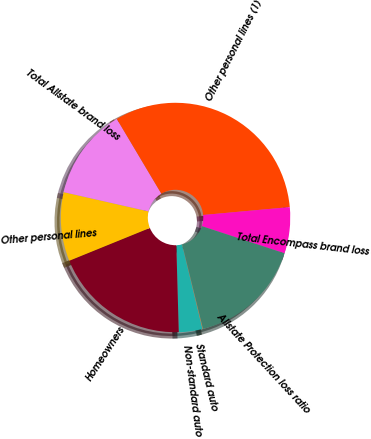Convert chart. <chart><loc_0><loc_0><loc_500><loc_500><pie_chart><fcel>Standard auto<fcel>Non-standard auto<fcel>Homeowners<fcel>Other personal lines<fcel>Total Allstate brand loss<fcel>Other personal lines (1)<fcel>Total Encompass brand loss<fcel>Allstate Protection loss ratio<nl><fcel>0.1%<fcel>3.3%<fcel>19.3%<fcel>9.7%<fcel>12.9%<fcel>32.1%<fcel>6.5%<fcel>16.1%<nl></chart> 